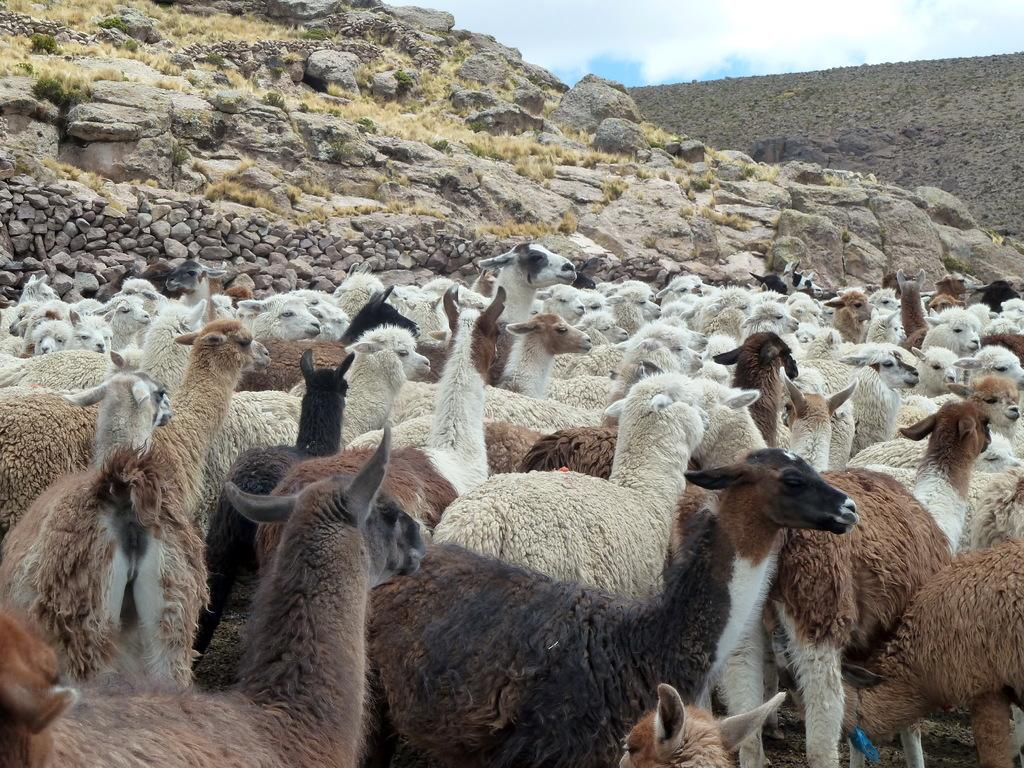What animals can be seen in the image? There are sheep in the image. What can be seen in the background of the image? The sky, clouds, hills, stones, and grass are visible in the background of the image. What type of music can be heard playing in the background of the image? There is no music present in the image; it is a visual representation of sheep and the background landscape. 